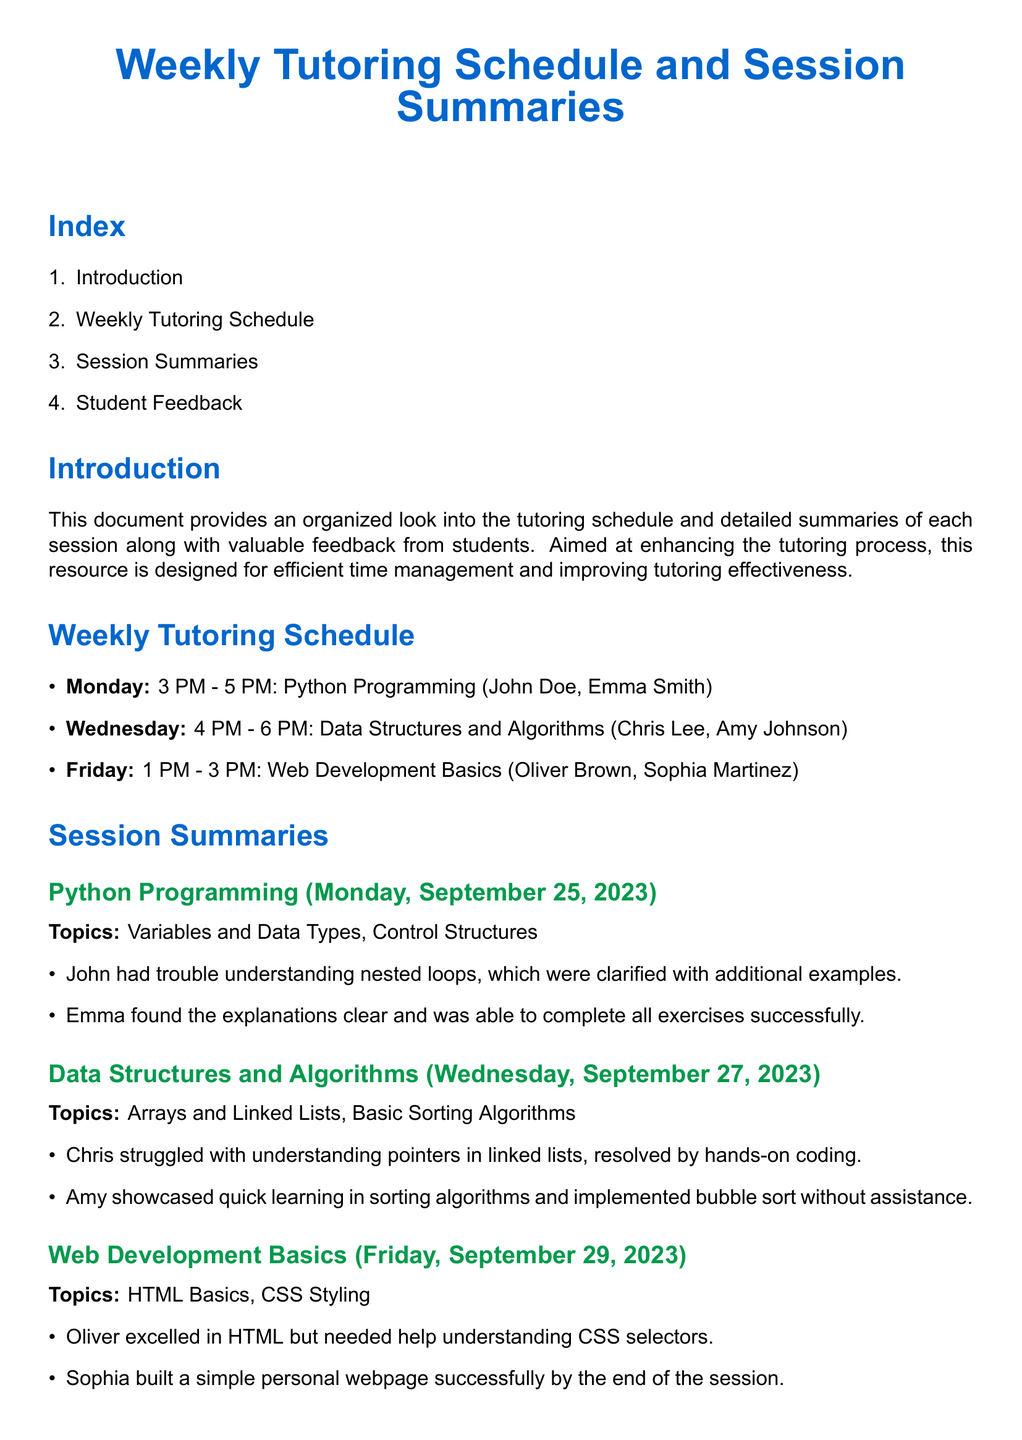what is the time for the Python Programming session? The document lists the time for the Python Programming session as 3 PM - 5 PM on Monday.
Answer: 3 PM - 5 PM who is the tutor for Data Structures and Algorithms? The session summaries do not specify a tutor's name for Data Structures and Algorithms.
Answer: Not specified which topic did Oliver excel in during the Web Development Basics session? According to the session summaries, Oliver excelled in HTML.
Answer: HTML how many students attended the Python Programming session? The document indicates that two students, John Doe and Emma Smith, attended the Python Programming session.
Answer: 2 students what did Chris Lee struggle with during the Data Structures and Algorithms session? The session summary states that Chris struggled with understanding pointers in linked lists.
Answer: pointers in linked lists what was Sophia Martinez's accomplishment by the end of the Web Development Basics session? The document notes that Sophia built a simple personal webpage successfully by the end of the session.
Answer: built a simple personal webpage what feedback did Amy Johnson provide about learning sorting algorithms? Amy Johnson mentioned that learning sorting algorithms was fun and engaging.
Answer: fun and engaging how many tutoring sessions are summarized in the document? The document summarizes three tutoring sessions: Python Programming, Data Structures and Algorithms, and Web Development Basics.
Answer: 3 sessions what color is used for the section titles in the document? The section titles are colored myblue.
Answer: myblue 